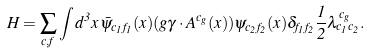Convert formula to latex. <formula><loc_0><loc_0><loc_500><loc_500>H = \sum _ { c , f } \int d ^ { 3 } { x } \, \bar { \psi } _ { c _ { 1 } f _ { 1 } } ( { x } ) ( g { \gamma } \cdot { A } ^ { c _ { g } } ( { x } ) ) \psi _ { c _ { 2 } f _ { 2 } } ( { x } ) \delta _ { f _ { 1 } f _ { 2 } } \frac { 1 } { 2 } \lambda ^ { c _ { g } } _ { c _ { 1 } c _ { 2 } } .</formula> 